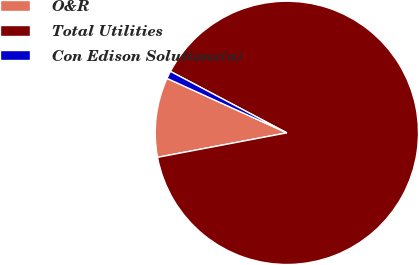Convert chart to OTSL. <chart><loc_0><loc_0><loc_500><loc_500><pie_chart><fcel>O&R<fcel>Total Utilities<fcel>Con Edison Solutions(a)<nl><fcel>9.77%<fcel>89.29%<fcel>0.94%<nl></chart> 